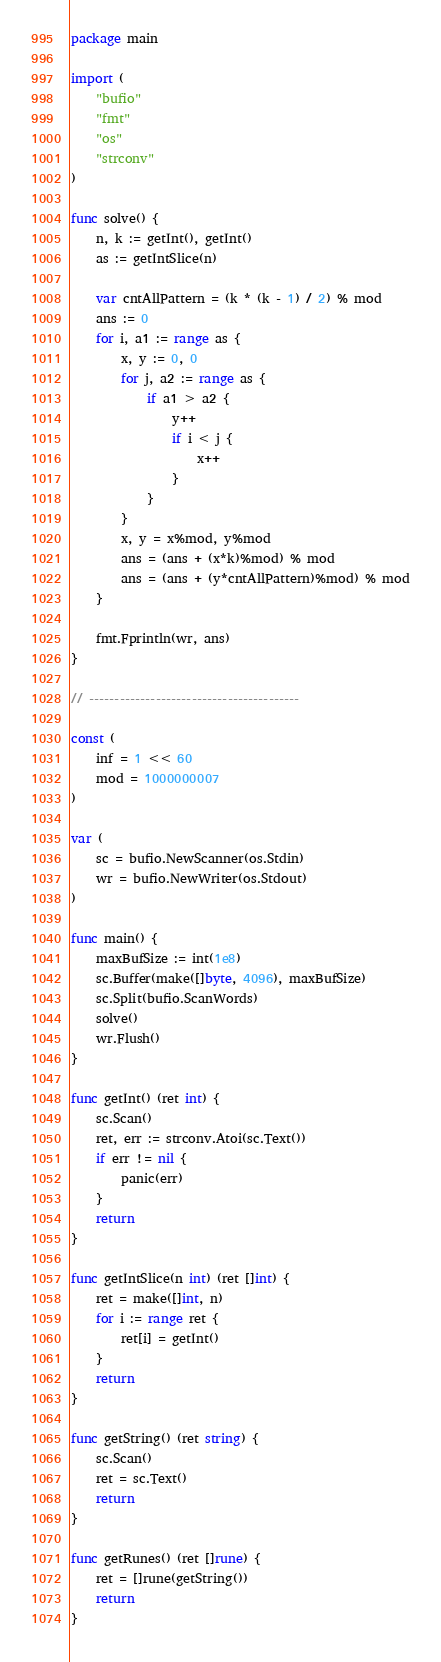<code> <loc_0><loc_0><loc_500><loc_500><_Go_>package main

import (
	"bufio"
	"fmt"
	"os"
	"strconv"
)

func solve() {
	n, k := getInt(), getInt()
	as := getIntSlice(n)

	var cntAllPattern = (k * (k - 1) / 2) % mod
	ans := 0
	for i, a1 := range as {
		x, y := 0, 0
		for j, a2 := range as {
			if a1 > a2 {
				y++
				if i < j {
					x++
				}
			}
		}
		x, y = x%mod, y%mod
		ans = (ans + (x*k)%mod) % mod
		ans = (ans + (y*cntAllPattern)%mod) % mod
	}

	fmt.Fprintln(wr, ans)
}

// -----------------------------------------

const (
	inf = 1 << 60
	mod = 1000000007
)

var (
	sc = bufio.NewScanner(os.Stdin)
	wr = bufio.NewWriter(os.Stdout)
)

func main() {
	maxBufSize := int(1e8)
	sc.Buffer(make([]byte, 4096), maxBufSize)
	sc.Split(bufio.ScanWords)
	solve()
	wr.Flush()
}

func getInt() (ret int) {
	sc.Scan()
	ret, err := strconv.Atoi(sc.Text())
	if err != nil {
		panic(err)
	}
	return
}

func getIntSlice(n int) (ret []int) {
	ret = make([]int, n)
	for i := range ret {
		ret[i] = getInt()
	}
	return
}

func getString() (ret string) {
	sc.Scan()
	ret = sc.Text()
	return
}

func getRunes() (ret []rune) {
	ret = []rune(getString())
	return
}
</code> 